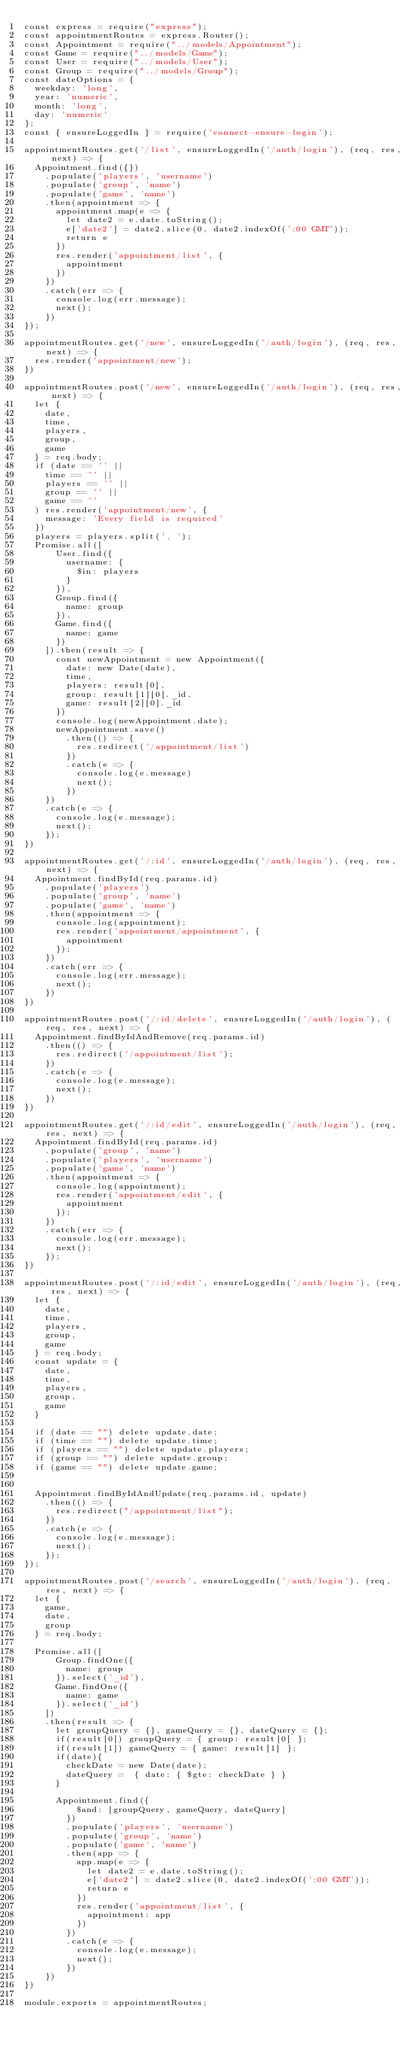<code> <loc_0><loc_0><loc_500><loc_500><_JavaScript_>const express = require("express");
const appointmentRoutes = express.Router();
const Appointment = require("../models/Appointment");
const Game = require("../models/Game");
const User = require("../models/User");
const Group = require("../models/Group");
const dateOptions = {
  weekday: 'long',
  year: 'numeric',
  month: 'long',
  day: 'numeric'
};
const { ensureLoggedIn } = require('connect-ensure-login');

appointmentRoutes.get('/list', ensureLoggedIn('/auth/login'), (req, res, next) => {
  Appointment.find({})
    .populate('players', 'username')
    .populate('group', 'name')
    .populate('game', 'name')
    .then(appointment => {
      appointment.map(e => {
        let date2 = e.date.toString();
        e['date2'] = date2.slice(0, date2.indexOf(':00 GMT'));
        return e
      })
      res.render('appointment/list', {
        appointment
      })
    })
    .catch(err => {
      console.log(err.message);
      next();
    })
});

appointmentRoutes.get('/new', ensureLoggedIn('/auth/login'), (req, res, next) => {
  res.render('appointment/new');
})

appointmentRoutes.post('/new', ensureLoggedIn('/auth/login'), (req, res, next) => {
  let {
    date,
    time,
    players,
    group,
    game
  } = req.body;
  if (date == '' ||
    time == '' ||
    players == '' ||
    group == '' ||
    game == ''
  ) res.render('appointment/new', {
    message: 'Every field is required'
  })
  players = players.split(', ');
  Promise.all([
      User.find({
        username: {
          $in: players
        }
      }),
      Group.find({
        name: group
      }),
      Game.find({
        name: game
      })
    ]).then(result => {
      const newAppointment = new Appointment({
        date: new Date(date),
        time,
        players: result[0],
        group: result[1][0]._id,
        game: result[2][0]._id
      })
      console.log(newAppointment.date);
      newAppointment.save()
        .then(() => {
          res.redirect('/appointment/list')
        })
        .catch(e => {
          console.log(e.message)
          next();
        })
    })
    .catch(e => {
      console.log(e.message);
      next();
    });
})

appointmentRoutes.get('/:id', ensureLoggedIn('/auth/login'), (req, res, next) => {
  Appointment.findById(req.params.id)
    .populate('players')
    .populate('group', 'name')
    .populate('game', 'name')
    .then(appointment => {
      console.log(appointment);
      res.render('appointment/appointment', {
        appointment
      });
    })
    .catch(err => {
      console.log(err.message);
      next();
    })
})

appointmentRoutes.post('/:id/delete', ensureLoggedIn('/auth/login'), (req, res, next) => {
  Appointment.findByIdAndRemove(req.params.id)
    .then(() => {
      res.redirect('/appointment/list');
    })
    .catch(e => {
      console.log(e.message);
      next();
    })
})

appointmentRoutes.get('/:id/edit', ensureLoggedIn('/auth/login'), (req, res, next) => {
  Appointment.findById(req.params.id)
    .populate('group', 'name')
    .populate('players', 'username')
    .populate('game', 'name')
    .then(appointment => {
      console.log(appointment);
      res.render('appointment/edit', {
        appointment
      });
    })
    .catch(err => {
      console.log(err.message);
      next();
    });
})

appointmentRoutes.post('/:id/edit', ensureLoggedIn('/auth/login'), (req, res, next) => {
  let {
    date,
    time,
    players,
    group,
    game
  } = req.body;
  const update = {
    date,
    time,
    players,
    group,
    game
  }

  if (date == "") delete update.date;
  if (time == "") delete update.time;
  if (players == "") delete update.players;
  if (group == "") delete update.group;
  if (game == "") delete update.game;


  Appointment.findByIdAndUpdate(req.params.id, update)
    .then(() => {
      res.redirect("/appointment/list");
    })
    .catch(e => {
      console.log(e.message);
      next();
    });
});

appointmentRoutes.post('/search', ensureLoggedIn('/auth/login'), (req, res, next) => {
  let {
    game,
    date,
    group
  } = req.body;

  Promise.all([
      Group.findOne({
        name: group
      }).select('_id'),
      Game.findOne({
        name: game
      }).select('_id')
    ])
    .then(result => {
      let groupQuery = {}, gameQuery = {}, dateQuery = {};
      if(result[0]) groupQuery = { group: result[0] };
      if(result[1]) gameQuery = { game: result[1] };
      if(date){
        checkDate = new Date(date);
        dateQuery =  { date: { $gte: checkDate } }
      } 

      Appointment.find({
          $and: [groupQuery, gameQuery, dateQuery]
        })
        .populate('players', 'username')
        .populate('group', 'name')
        .populate('game', 'name')
        .then(app => {
          app.map(e => {
            let date2 = e.date.toString();
            e['date2'] = date2.slice(0, date2.indexOf(':00 GMT'));
            return e
          })
          res.render('appointment/list', {
            appointment: app
          })
        })
        .catch(e => {
          console.log(e.message);
          next();
        })
    })
})

module.exports = appointmentRoutes;</code> 